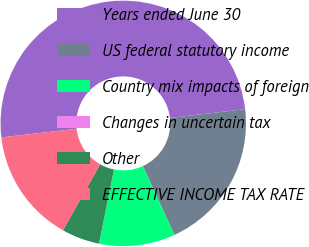<chart> <loc_0><loc_0><loc_500><loc_500><pie_chart><fcel>Years ended June 30<fcel>US federal statutory income<fcel>Country mix impacts of foreign<fcel>Changes in uncertain tax<fcel>Other<fcel>EFFECTIVE INCOME TAX RATE<nl><fcel>49.98%<fcel>20.0%<fcel>10.0%<fcel>0.01%<fcel>5.01%<fcel>15.0%<nl></chart> 